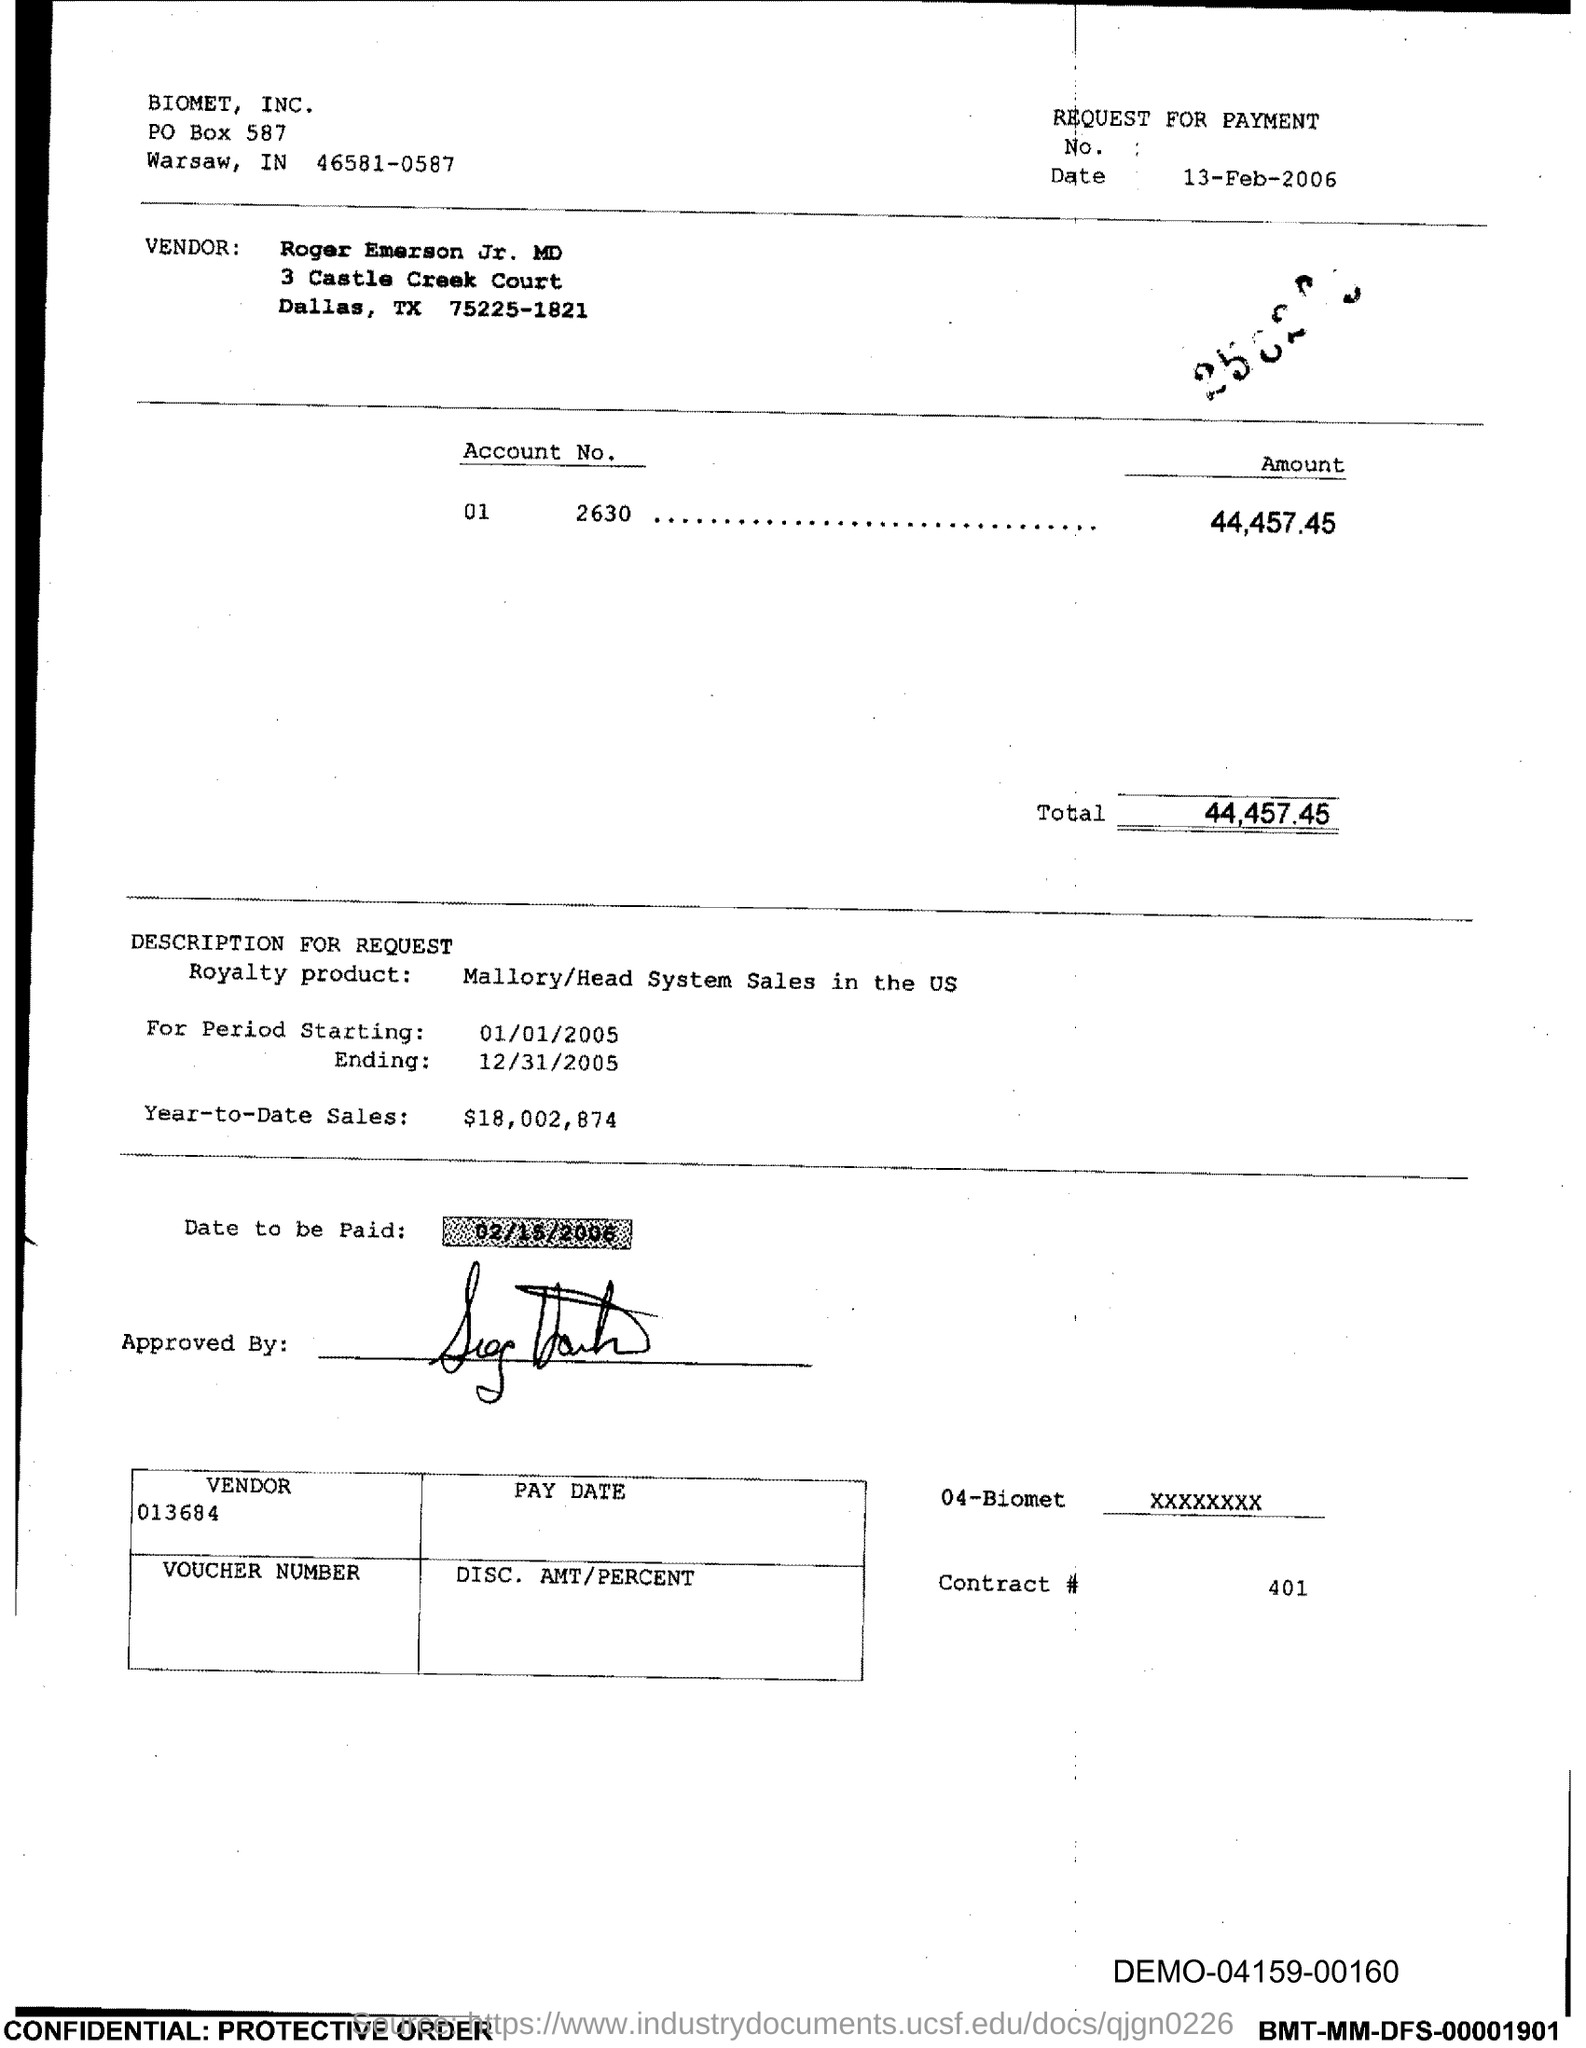Give some essential details in this illustration. The question, "What is the Contract # Number? 401..." is a request for information and is best understood as an interrogative sentence. The PO Box number mentioned in the document is 587. The total is 44,457.45. 